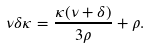<formula> <loc_0><loc_0><loc_500><loc_500>\nu \delta \kappa = \frac { \kappa ( \nu + \delta ) } { 3 \rho } + \rho .</formula> 